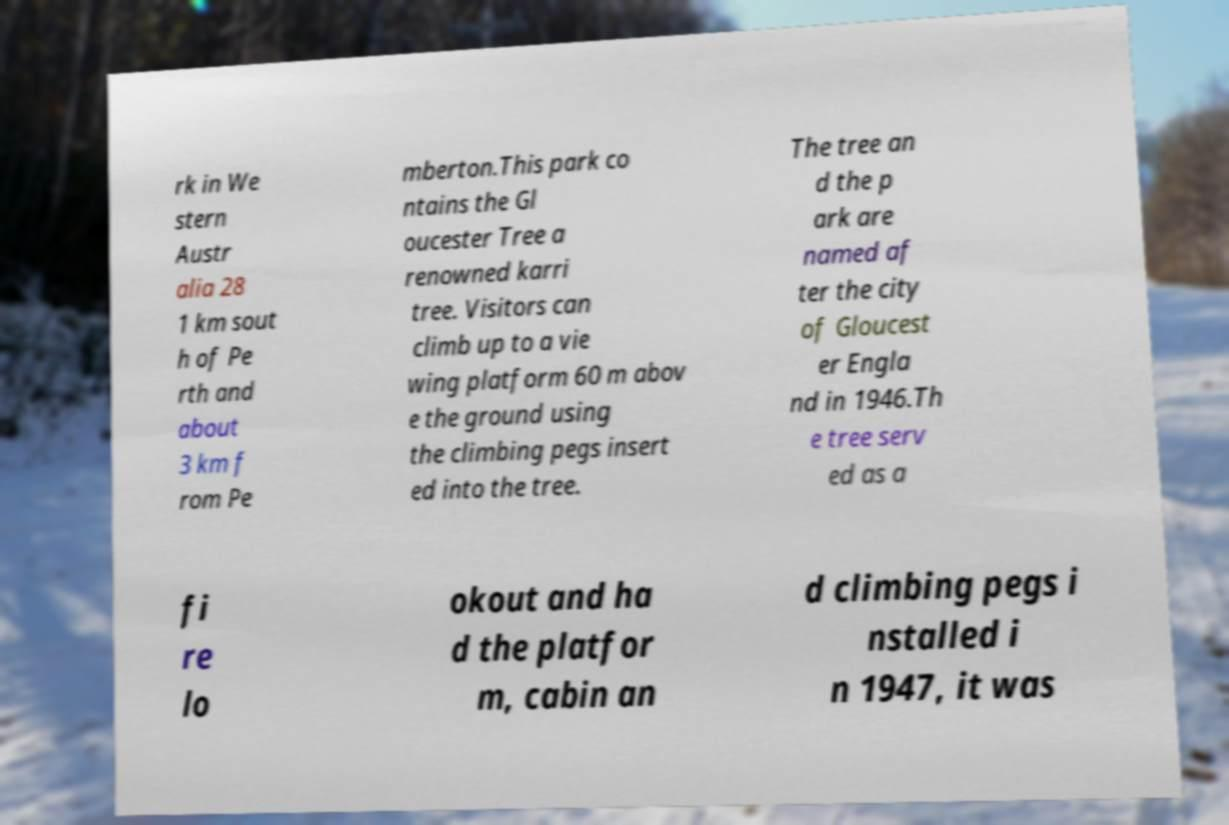Could you assist in decoding the text presented in this image and type it out clearly? rk in We stern Austr alia 28 1 km sout h of Pe rth and about 3 km f rom Pe mberton.This park co ntains the Gl oucester Tree a renowned karri tree. Visitors can climb up to a vie wing platform 60 m abov e the ground using the climbing pegs insert ed into the tree. The tree an d the p ark are named af ter the city of Gloucest er Engla nd in 1946.Th e tree serv ed as a fi re lo okout and ha d the platfor m, cabin an d climbing pegs i nstalled i n 1947, it was 